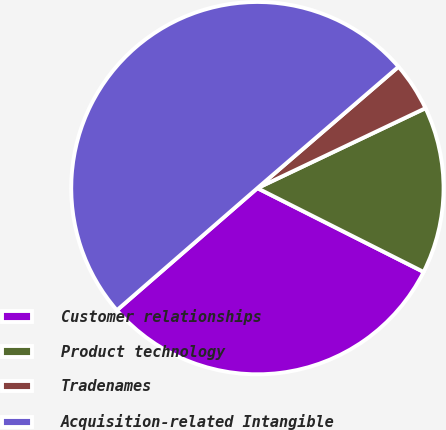<chart> <loc_0><loc_0><loc_500><loc_500><pie_chart><fcel>Customer relationships<fcel>Product technology<fcel>Tradenames<fcel>Acquisition-related Intangible<nl><fcel>31.18%<fcel>14.5%<fcel>4.24%<fcel>50.08%<nl></chart> 